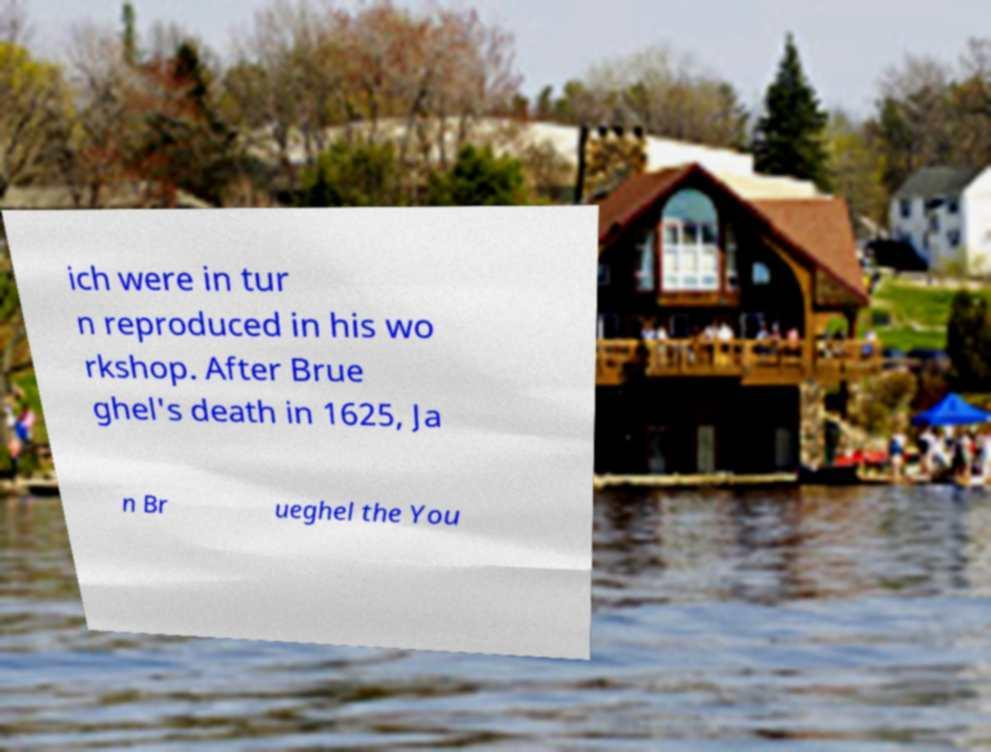Please read and relay the text visible in this image. What does it say? ich were in tur n reproduced in his wo rkshop. After Brue ghel's death in 1625, Ja n Br ueghel the You 